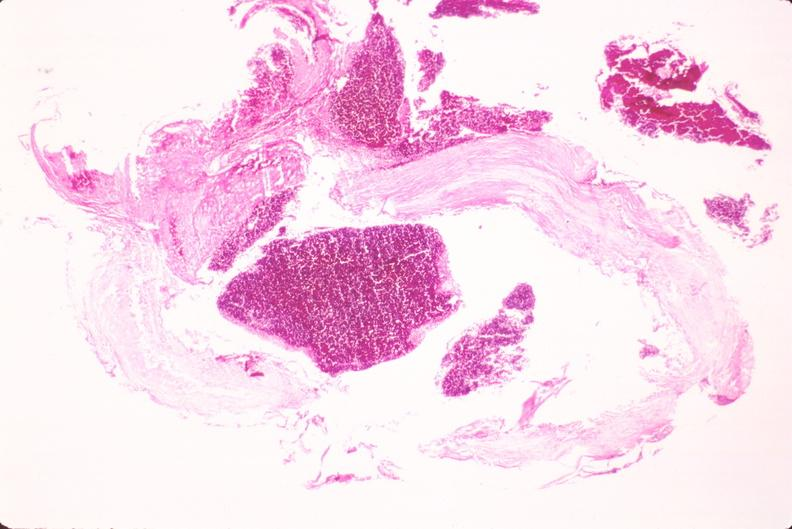what is present?
Answer the question using a single word or phrase. Cardiovascular 